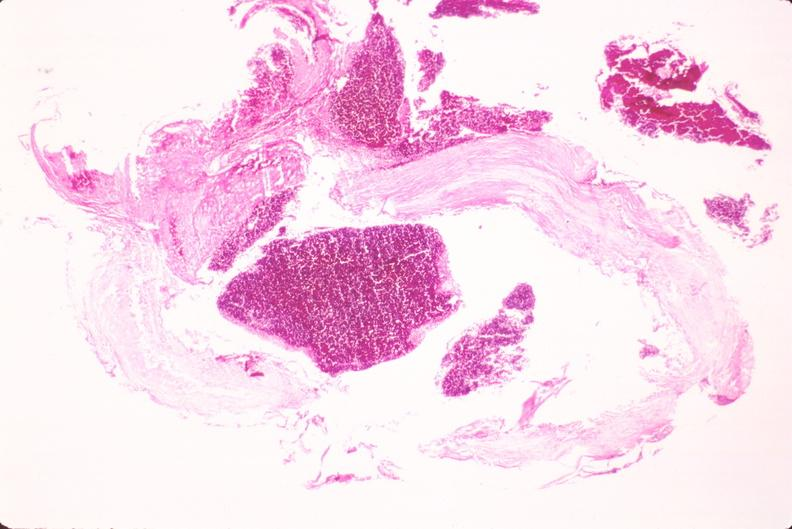what is present?
Answer the question using a single word or phrase. Cardiovascular 